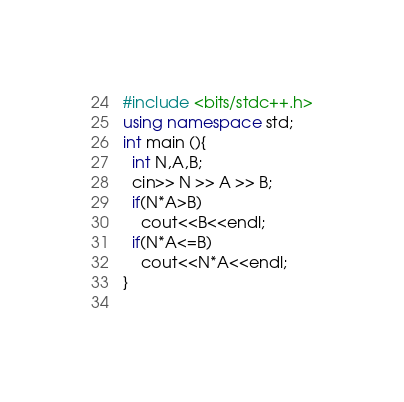<code> <loc_0><loc_0><loc_500><loc_500><_C++_>#include <bits/stdc++.h>
using namespace std;
int main (){
  int N,A,B;
  cin>> N >> A >> B;
  if(N*A>B) 
    cout<<B<<endl;
  if(N*A<=B)
    cout<<N*A<<endl;
}
  
</code> 